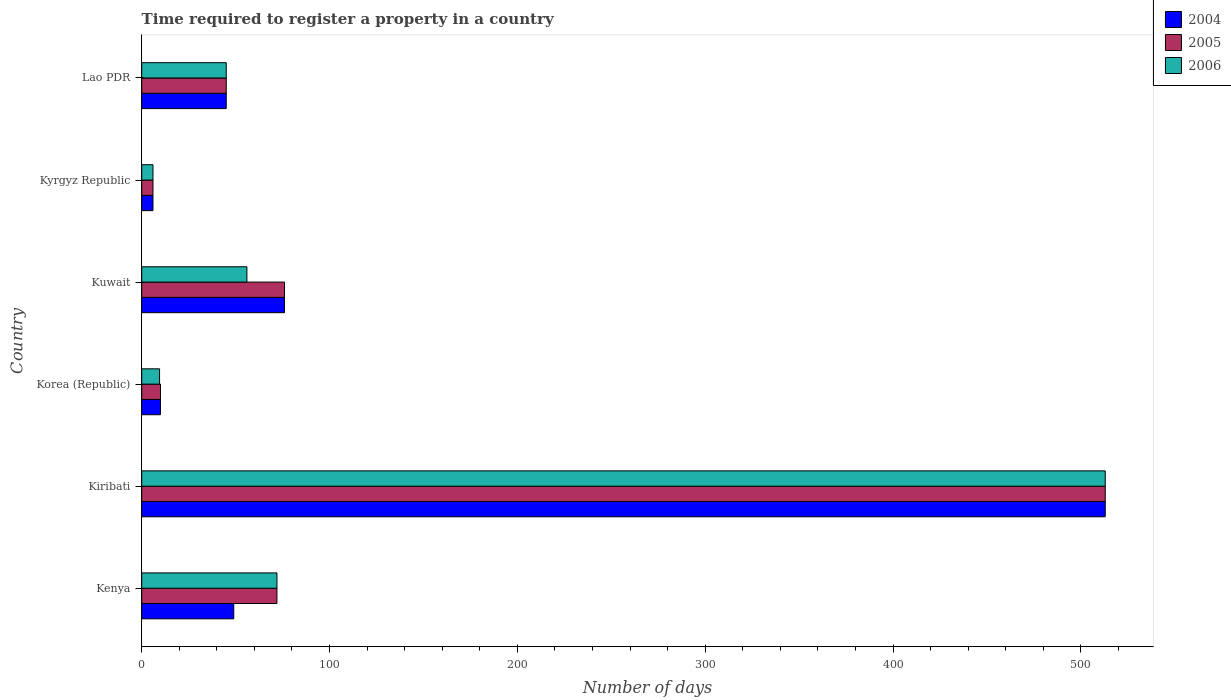How many groups of bars are there?
Ensure brevity in your answer.  6. What is the label of the 6th group of bars from the top?
Your answer should be compact. Kenya. Across all countries, what is the maximum number of days required to register a property in 2005?
Your answer should be compact. 513. Across all countries, what is the minimum number of days required to register a property in 2005?
Your response must be concise. 6. In which country was the number of days required to register a property in 2005 maximum?
Give a very brief answer. Kiribati. In which country was the number of days required to register a property in 2005 minimum?
Give a very brief answer. Kyrgyz Republic. What is the total number of days required to register a property in 2006 in the graph?
Offer a very short reply. 701.5. What is the average number of days required to register a property in 2005 per country?
Make the answer very short. 120.33. What is the difference between the number of days required to register a property in 2005 and number of days required to register a property in 2004 in Kenya?
Your response must be concise. 23. In how many countries, is the number of days required to register a property in 2005 greater than 100 days?
Make the answer very short. 1. What is the ratio of the number of days required to register a property in 2004 in Kiribati to that in Lao PDR?
Give a very brief answer. 11.4. Is the number of days required to register a property in 2005 in Kenya less than that in Kiribati?
Offer a terse response. Yes. What is the difference between the highest and the second highest number of days required to register a property in 2004?
Make the answer very short. 437. What is the difference between the highest and the lowest number of days required to register a property in 2005?
Make the answer very short. 507. What does the 1st bar from the top in Korea (Republic) represents?
Your answer should be very brief. 2006. What does the 3rd bar from the bottom in Korea (Republic) represents?
Provide a short and direct response. 2006. Is it the case that in every country, the sum of the number of days required to register a property in 2005 and number of days required to register a property in 2006 is greater than the number of days required to register a property in 2004?
Your answer should be very brief. Yes. Are all the bars in the graph horizontal?
Offer a very short reply. Yes. Are the values on the major ticks of X-axis written in scientific E-notation?
Provide a short and direct response. No. Does the graph contain any zero values?
Offer a terse response. No. What is the title of the graph?
Your response must be concise. Time required to register a property in a country. Does "1978" appear as one of the legend labels in the graph?
Give a very brief answer. No. What is the label or title of the X-axis?
Provide a succinct answer. Number of days. What is the Number of days of 2004 in Kenya?
Keep it short and to the point. 49. What is the Number of days of 2005 in Kenya?
Provide a short and direct response. 72. What is the Number of days of 2004 in Kiribati?
Ensure brevity in your answer.  513. What is the Number of days in 2005 in Kiribati?
Give a very brief answer. 513. What is the Number of days in 2006 in Kiribati?
Your response must be concise. 513. What is the Number of days in 2004 in Korea (Republic)?
Give a very brief answer. 10. What is the Number of days of 2006 in Korea (Republic)?
Provide a short and direct response. 9.5. What is the Number of days of 2006 in Kuwait?
Ensure brevity in your answer.  56. What is the Number of days in 2004 in Kyrgyz Republic?
Your response must be concise. 6. What is the Number of days of 2005 in Kyrgyz Republic?
Your response must be concise. 6. Across all countries, what is the maximum Number of days of 2004?
Your answer should be compact. 513. Across all countries, what is the maximum Number of days in 2005?
Give a very brief answer. 513. Across all countries, what is the maximum Number of days in 2006?
Offer a very short reply. 513. Across all countries, what is the minimum Number of days in 2006?
Ensure brevity in your answer.  6. What is the total Number of days in 2004 in the graph?
Your answer should be compact. 699. What is the total Number of days in 2005 in the graph?
Provide a succinct answer. 722. What is the total Number of days of 2006 in the graph?
Ensure brevity in your answer.  701.5. What is the difference between the Number of days of 2004 in Kenya and that in Kiribati?
Make the answer very short. -464. What is the difference between the Number of days in 2005 in Kenya and that in Kiribati?
Keep it short and to the point. -441. What is the difference between the Number of days in 2006 in Kenya and that in Kiribati?
Your response must be concise. -441. What is the difference between the Number of days of 2006 in Kenya and that in Korea (Republic)?
Ensure brevity in your answer.  62.5. What is the difference between the Number of days in 2004 in Kenya and that in Kuwait?
Your answer should be very brief. -27. What is the difference between the Number of days in 2004 in Kenya and that in Kyrgyz Republic?
Give a very brief answer. 43. What is the difference between the Number of days of 2005 in Kenya and that in Lao PDR?
Offer a very short reply. 27. What is the difference between the Number of days in 2006 in Kenya and that in Lao PDR?
Offer a very short reply. 27. What is the difference between the Number of days of 2004 in Kiribati and that in Korea (Republic)?
Provide a succinct answer. 503. What is the difference between the Number of days of 2005 in Kiribati and that in Korea (Republic)?
Your answer should be very brief. 503. What is the difference between the Number of days of 2006 in Kiribati and that in Korea (Republic)?
Ensure brevity in your answer.  503.5. What is the difference between the Number of days in 2004 in Kiribati and that in Kuwait?
Offer a very short reply. 437. What is the difference between the Number of days in 2005 in Kiribati and that in Kuwait?
Your answer should be very brief. 437. What is the difference between the Number of days of 2006 in Kiribati and that in Kuwait?
Provide a succinct answer. 457. What is the difference between the Number of days of 2004 in Kiribati and that in Kyrgyz Republic?
Your answer should be very brief. 507. What is the difference between the Number of days in 2005 in Kiribati and that in Kyrgyz Republic?
Offer a very short reply. 507. What is the difference between the Number of days of 2006 in Kiribati and that in Kyrgyz Republic?
Your response must be concise. 507. What is the difference between the Number of days in 2004 in Kiribati and that in Lao PDR?
Give a very brief answer. 468. What is the difference between the Number of days of 2005 in Kiribati and that in Lao PDR?
Your response must be concise. 468. What is the difference between the Number of days in 2006 in Kiribati and that in Lao PDR?
Give a very brief answer. 468. What is the difference between the Number of days in 2004 in Korea (Republic) and that in Kuwait?
Make the answer very short. -66. What is the difference between the Number of days in 2005 in Korea (Republic) and that in Kuwait?
Your answer should be compact. -66. What is the difference between the Number of days in 2006 in Korea (Republic) and that in Kuwait?
Ensure brevity in your answer.  -46.5. What is the difference between the Number of days of 2004 in Korea (Republic) and that in Kyrgyz Republic?
Ensure brevity in your answer.  4. What is the difference between the Number of days in 2006 in Korea (Republic) and that in Kyrgyz Republic?
Offer a terse response. 3.5. What is the difference between the Number of days in 2004 in Korea (Republic) and that in Lao PDR?
Provide a short and direct response. -35. What is the difference between the Number of days in 2005 in Korea (Republic) and that in Lao PDR?
Your answer should be compact. -35. What is the difference between the Number of days in 2006 in Korea (Republic) and that in Lao PDR?
Give a very brief answer. -35.5. What is the difference between the Number of days of 2004 in Kuwait and that in Kyrgyz Republic?
Your answer should be very brief. 70. What is the difference between the Number of days in 2005 in Kuwait and that in Kyrgyz Republic?
Your answer should be compact. 70. What is the difference between the Number of days of 2006 in Kuwait and that in Lao PDR?
Offer a very short reply. 11. What is the difference between the Number of days of 2004 in Kyrgyz Republic and that in Lao PDR?
Offer a terse response. -39. What is the difference between the Number of days of 2005 in Kyrgyz Republic and that in Lao PDR?
Make the answer very short. -39. What is the difference between the Number of days of 2006 in Kyrgyz Republic and that in Lao PDR?
Make the answer very short. -39. What is the difference between the Number of days in 2004 in Kenya and the Number of days in 2005 in Kiribati?
Your answer should be compact. -464. What is the difference between the Number of days in 2004 in Kenya and the Number of days in 2006 in Kiribati?
Offer a terse response. -464. What is the difference between the Number of days of 2005 in Kenya and the Number of days of 2006 in Kiribati?
Ensure brevity in your answer.  -441. What is the difference between the Number of days in 2004 in Kenya and the Number of days in 2005 in Korea (Republic)?
Your answer should be compact. 39. What is the difference between the Number of days in 2004 in Kenya and the Number of days in 2006 in Korea (Republic)?
Provide a short and direct response. 39.5. What is the difference between the Number of days of 2005 in Kenya and the Number of days of 2006 in Korea (Republic)?
Make the answer very short. 62.5. What is the difference between the Number of days in 2005 in Kenya and the Number of days in 2006 in Kyrgyz Republic?
Keep it short and to the point. 66. What is the difference between the Number of days of 2004 in Kenya and the Number of days of 2005 in Lao PDR?
Provide a short and direct response. 4. What is the difference between the Number of days of 2005 in Kenya and the Number of days of 2006 in Lao PDR?
Offer a very short reply. 27. What is the difference between the Number of days of 2004 in Kiribati and the Number of days of 2005 in Korea (Republic)?
Ensure brevity in your answer.  503. What is the difference between the Number of days of 2004 in Kiribati and the Number of days of 2006 in Korea (Republic)?
Keep it short and to the point. 503.5. What is the difference between the Number of days in 2005 in Kiribati and the Number of days in 2006 in Korea (Republic)?
Provide a succinct answer. 503.5. What is the difference between the Number of days of 2004 in Kiribati and the Number of days of 2005 in Kuwait?
Your answer should be very brief. 437. What is the difference between the Number of days in 2004 in Kiribati and the Number of days in 2006 in Kuwait?
Keep it short and to the point. 457. What is the difference between the Number of days of 2005 in Kiribati and the Number of days of 2006 in Kuwait?
Offer a very short reply. 457. What is the difference between the Number of days in 2004 in Kiribati and the Number of days in 2005 in Kyrgyz Republic?
Ensure brevity in your answer.  507. What is the difference between the Number of days in 2004 in Kiribati and the Number of days in 2006 in Kyrgyz Republic?
Your response must be concise. 507. What is the difference between the Number of days of 2005 in Kiribati and the Number of days of 2006 in Kyrgyz Republic?
Your response must be concise. 507. What is the difference between the Number of days of 2004 in Kiribati and the Number of days of 2005 in Lao PDR?
Provide a succinct answer. 468. What is the difference between the Number of days of 2004 in Kiribati and the Number of days of 2006 in Lao PDR?
Your answer should be compact. 468. What is the difference between the Number of days in 2005 in Kiribati and the Number of days in 2006 in Lao PDR?
Provide a succinct answer. 468. What is the difference between the Number of days of 2004 in Korea (Republic) and the Number of days of 2005 in Kuwait?
Your response must be concise. -66. What is the difference between the Number of days in 2004 in Korea (Republic) and the Number of days in 2006 in Kuwait?
Your answer should be compact. -46. What is the difference between the Number of days of 2005 in Korea (Republic) and the Number of days of 2006 in Kuwait?
Your response must be concise. -46. What is the difference between the Number of days of 2004 in Korea (Republic) and the Number of days of 2005 in Kyrgyz Republic?
Your response must be concise. 4. What is the difference between the Number of days in 2004 in Korea (Republic) and the Number of days in 2005 in Lao PDR?
Provide a short and direct response. -35. What is the difference between the Number of days in 2004 in Korea (Republic) and the Number of days in 2006 in Lao PDR?
Offer a very short reply. -35. What is the difference between the Number of days of 2005 in Korea (Republic) and the Number of days of 2006 in Lao PDR?
Offer a very short reply. -35. What is the difference between the Number of days in 2004 in Kuwait and the Number of days in 2005 in Kyrgyz Republic?
Keep it short and to the point. 70. What is the difference between the Number of days in 2004 in Kuwait and the Number of days in 2006 in Kyrgyz Republic?
Make the answer very short. 70. What is the difference between the Number of days in 2004 in Kuwait and the Number of days in 2005 in Lao PDR?
Give a very brief answer. 31. What is the difference between the Number of days of 2005 in Kuwait and the Number of days of 2006 in Lao PDR?
Provide a short and direct response. 31. What is the difference between the Number of days in 2004 in Kyrgyz Republic and the Number of days in 2005 in Lao PDR?
Your response must be concise. -39. What is the difference between the Number of days of 2004 in Kyrgyz Republic and the Number of days of 2006 in Lao PDR?
Provide a short and direct response. -39. What is the difference between the Number of days in 2005 in Kyrgyz Republic and the Number of days in 2006 in Lao PDR?
Keep it short and to the point. -39. What is the average Number of days of 2004 per country?
Your response must be concise. 116.5. What is the average Number of days in 2005 per country?
Your answer should be very brief. 120.33. What is the average Number of days of 2006 per country?
Your answer should be very brief. 116.92. What is the difference between the Number of days of 2004 and Number of days of 2005 in Kenya?
Your response must be concise. -23. What is the difference between the Number of days in 2005 and Number of days in 2006 in Kiribati?
Ensure brevity in your answer.  0. What is the difference between the Number of days of 2004 and Number of days of 2006 in Korea (Republic)?
Make the answer very short. 0.5. What is the difference between the Number of days of 2005 and Number of days of 2006 in Korea (Republic)?
Offer a very short reply. 0.5. What is the difference between the Number of days in 2005 and Number of days in 2006 in Kuwait?
Offer a terse response. 20. What is the difference between the Number of days of 2004 and Number of days of 2005 in Kyrgyz Republic?
Ensure brevity in your answer.  0. What is the difference between the Number of days in 2004 and Number of days in 2006 in Kyrgyz Republic?
Your response must be concise. 0. What is the difference between the Number of days of 2004 and Number of days of 2005 in Lao PDR?
Your response must be concise. 0. What is the difference between the Number of days in 2004 and Number of days in 2006 in Lao PDR?
Your response must be concise. 0. What is the difference between the Number of days in 2005 and Number of days in 2006 in Lao PDR?
Offer a very short reply. 0. What is the ratio of the Number of days of 2004 in Kenya to that in Kiribati?
Your answer should be very brief. 0.1. What is the ratio of the Number of days of 2005 in Kenya to that in Kiribati?
Ensure brevity in your answer.  0.14. What is the ratio of the Number of days in 2006 in Kenya to that in Kiribati?
Keep it short and to the point. 0.14. What is the ratio of the Number of days in 2005 in Kenya to that in Korea (Republic)?
Provide a succinct answer. 7.2. What is the ratio of the Number of days in 2006 in Kenya to that in Korea (Republic)?
Provide a succinct answer. 7.58. What is the ratio of the Number of days in 2004 in Kenya to that in Kuwait?
Provide a succinct answer. 0.64. What is the ratio of the Number of days in 2006 in Kenya to that in Kuwait?
Give a very brief answer. 1.29. What is the ratio of the Number of days of 2004 in Kenya to that in Kyrgyz Republic?
Your answer should be very brief. 8.17. What is the ratio of the Number of days of 2005 in Kenya to that in Kyrgyz Republic?
Your answer should be very brief. 12. What is the ratio of the Number of days of 2006 in Kenya to that in Kyrgyz Republic?
Provide a succinct answer. 12. What is the ratio of the Number of days in 2004 in Kenya to that in Lao PDR?
Give a very brief answer. 1.09. What is the ratio of the Number of days in 2004 in Kiribati to that in Korea (Republic)?
Give a very brief answer. 51.3. What is the ratio of the Number of days in 2005 in Kiribati to that in Korea (Republic)?
Keep it short and to the point. 51.3. What is the ratio of the Number of days in 2004 in Kiribati to that in Kuwait?
Give a very brief answer. 6.75. What is the ratio of the Number of days of 2005 in Kiribati to that in Kuwait?
Give a very brief answer. 6.75. What is the ratio of the Number of days in 2006 in Kiribati to that in Kuwait?
Your answer should be very brief. 9.16. What is the ratio of the Number of days of 2004 in Kiribati to that in Kyrgyz Republic?
Provide a short and direct response. 85.5. What is the ratio of the Number of days of 2005 in Kiribati to that in Kyrgyz Republic?
Offer a terse response. 85.5. What is the ratio of the Number of days of 2006 in Kiribati to that in Kyrgyz Republic?
Ensure brevity in your answer.  85.5. What is the ratio of the Number of days in 2004 in Kiribati to that in Lao PDR?
Your answer should be compact. 11.4. What is the ratio of the Number of days in 2005 in Kiribati to that in Lao PDR?
Offer a very short reply. 11.4. What is the ratio of the Number of days of 2004 in Korea (Republic) to that in Kuwait?
Keep it short and to the point. 0.13. What is the ratio of the Number of days of 2005 in Korea (Republic) to that in Kuwait?
Your answer should be very brief. 0.13. What is the ratio of the Number of days in 2006 in Korea (Republic) to that in Kuwait?
Offer a very short reply. 0.17. What is the ratio of the Number of days in 2004 in Korea (Republic) to that in Kyrgyz Republic?
Your response must be concise. 1.67. What is the ratio of the Number of days of 2005 in Korea (Republic) to that in Kyrgyz Republic?
Provide a short and direct response. 1.67. What is the ratio of the Number of days of 2006 in Korea (Republic) to that in Kyrgyz Republic?
Provide a short and direct response. 1.58. What is the ratio of the Number of days of 2004 in Korea (Republic) to that in Lao PDR?
Ensure brevity in your answer.  0.22. What is the ratio of the Number of days of 2005 in Korea (Republic) to that in Lao PDR?
Ensure brevity in your answer.  0.22. What is the ratio of the Number of days of 2006 in Korea (Republic) to that in Lao PDR?
Your answer should be compact. 0.21. What is the ratio of the Number of days of 2004 in Kuwait to that in Kyrgyz Republic?
Offer a terse response. 12.67. What is the ratio of the Number of days in 2005 in Kuwait to that in Kyrgyz Republic?
Provide a short and direct response. 12.67. What is the ratio of the Number of days of 2006 in Kuwait to that in Kyrgyz Republic?
Make the answer very short. 9.33. What is the ratio of the Number of days in 2004 in Kuwait to that in Lao PDR?
Offer a terse response. 1.69. What is the ratio of the Number of days in 2005 in Kuwait to that in Lao PDR?
Provide a short and direct response. 1.69. What is the ratio of the Number of days of 2006 in Kuwait to that in Lao PDR?
Keep it short and to the point. 1.24. What is the ratio of the Number of days of 2004 in Kyrgyz Republic to that in Lao PDR?
Your answer should be very brief. 0.13. What is the ratio of the Number of days of 2005 in Kyrgyz Republic to that in Lao PDR?
Give a very brief answer. 0.13. What is the ratio of the Number of days of 2006 in Kyrgyz Republic to that in Lao PDR?
Make the answer very short. 0.13. What is the difference between the highest and the second highest Number of days of 2004?
Provide a succinct answer. 437. What is the difference between the highest and the second highest Number of days in 2005?
Ensure brevity in your answer.  437. What is the difference between the highest and the second highest Number of days in 2006?
Provide a succinct answer. 441. What is the difference between the highest and the lowest Number of days in 2004?
Keep it short and to the point. 507. What is the difference between the highest and the lowest Number of days of 2005?
Provide a short and direct response. 507. What is the difference between the highest and the lowest Number of days in 2006?
Your answer should be very brief. 507. 